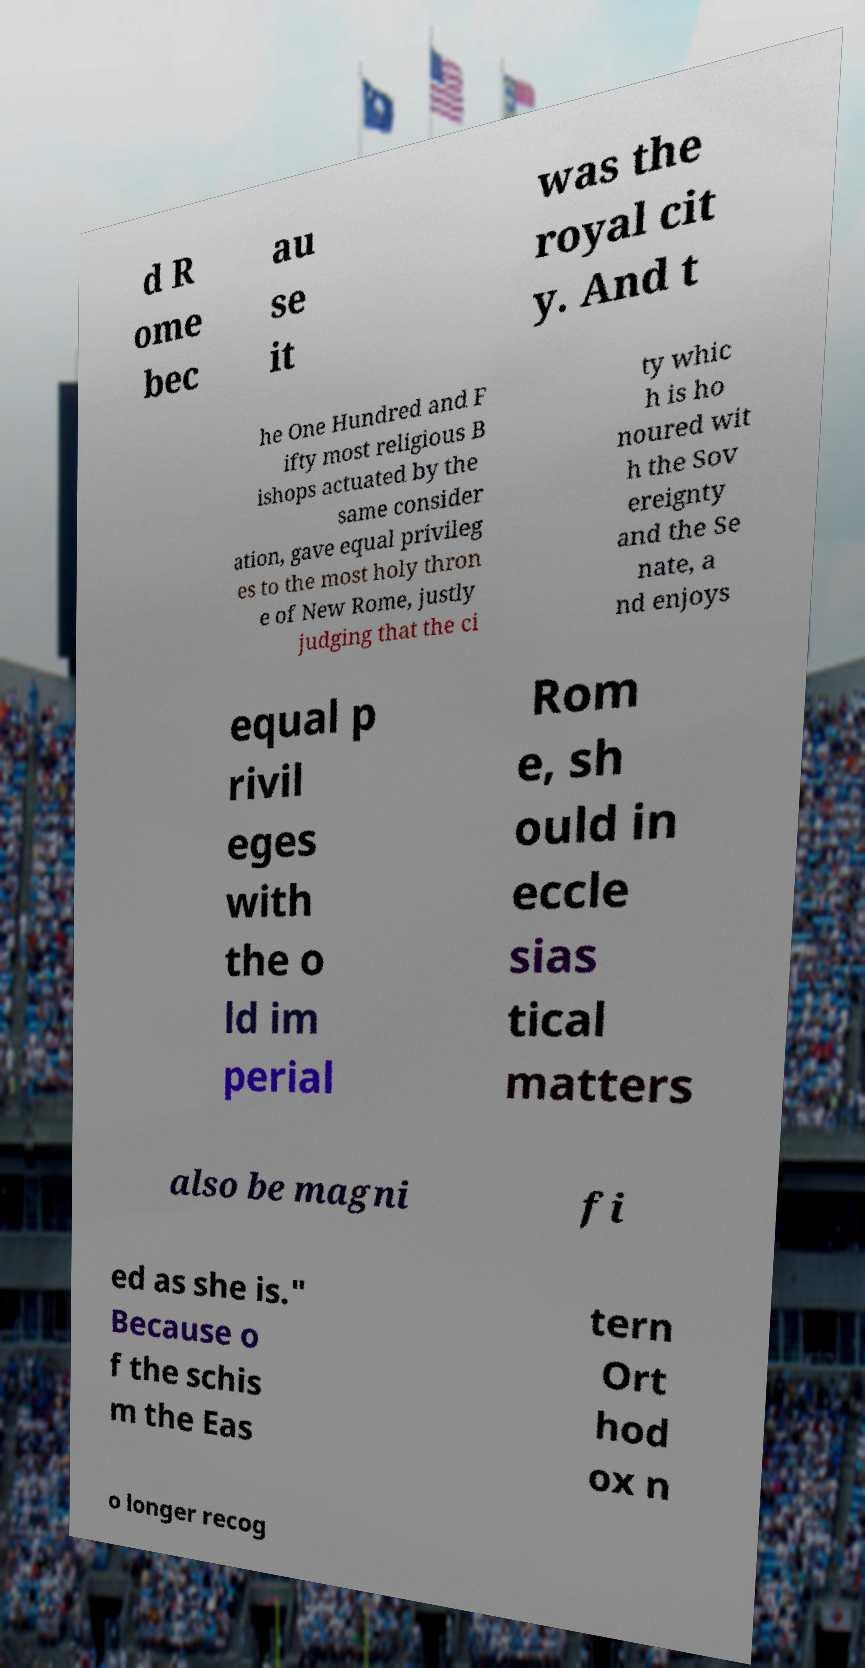Could you extract and type out the text from this image? d R ome bec au se it was the royal cit y. And t he One Hundred and F ifty most religious B ishops actuated by the same consider ation, gave equal privileg es to the most holy thron e of New Rome, justly judging that the ci ty whic h is ho noured wit h the Sov ereignty and the Se nate, a nd enjoys equal p rivil eges with the o ld im perial Rom e, sh ould in eccle sias tical matters also be magni fi ed as she is." Because o f the schis m the Eas tern Ort hod ox n o longer recog 